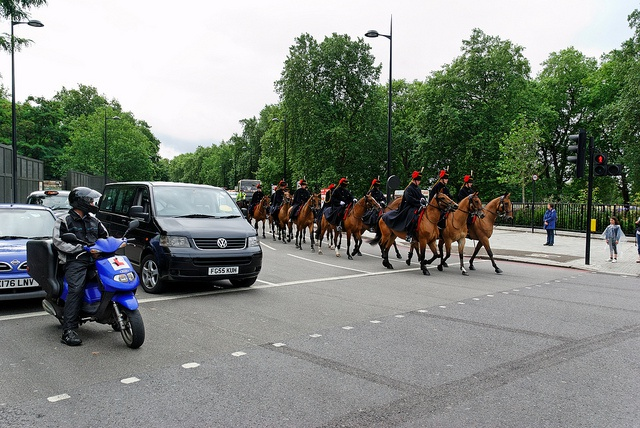Describe the objects in this image and their specific colors. I can see truck in darkgreen, black, lightgray, and darkgray tones, car in darkgreen, black, lightgray, darkgray, and gray tones, motorcycle in darkgreen, black, gray, navy, and darkblue tones, people in darkgreen, black, gray, darkgray, and navy tones, and car in darkgreen, lightgray, black, and darkgray tones in this image. 